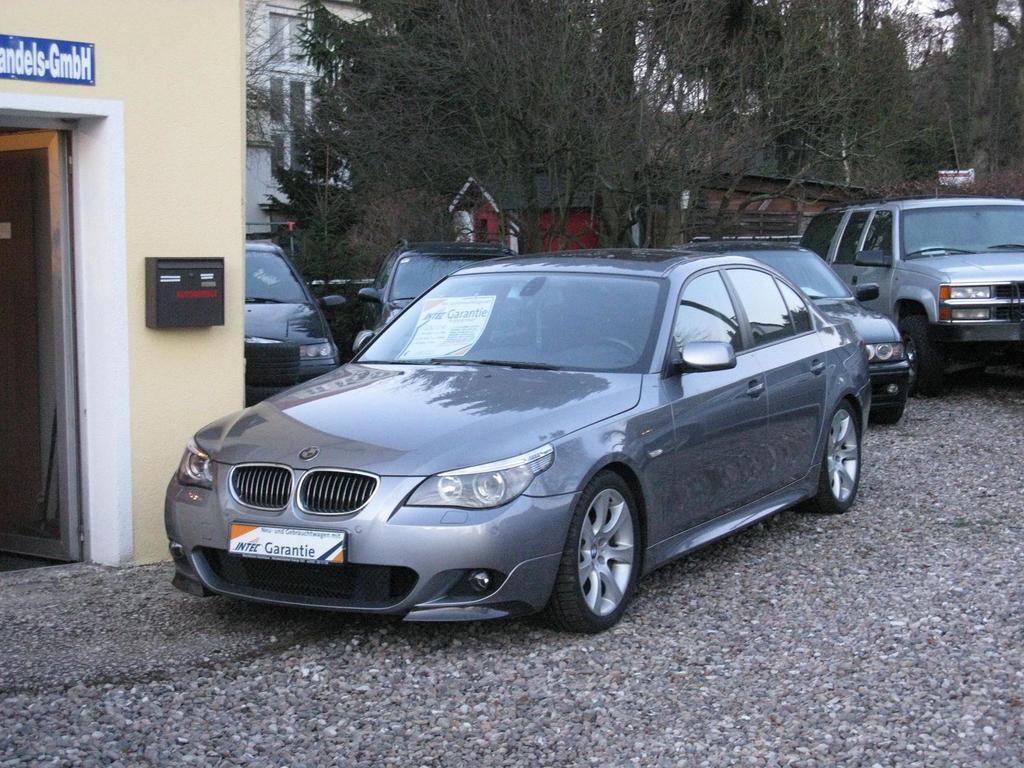In one or two sentences, can you explain what this image depicts? In this image there are cars parked on the ground one beside the other. At the bottom there are stones. In the background there are trees. Behind the trees there is a building. On the left side there is a door. Beside the door there is a post box fixed to the wall. 